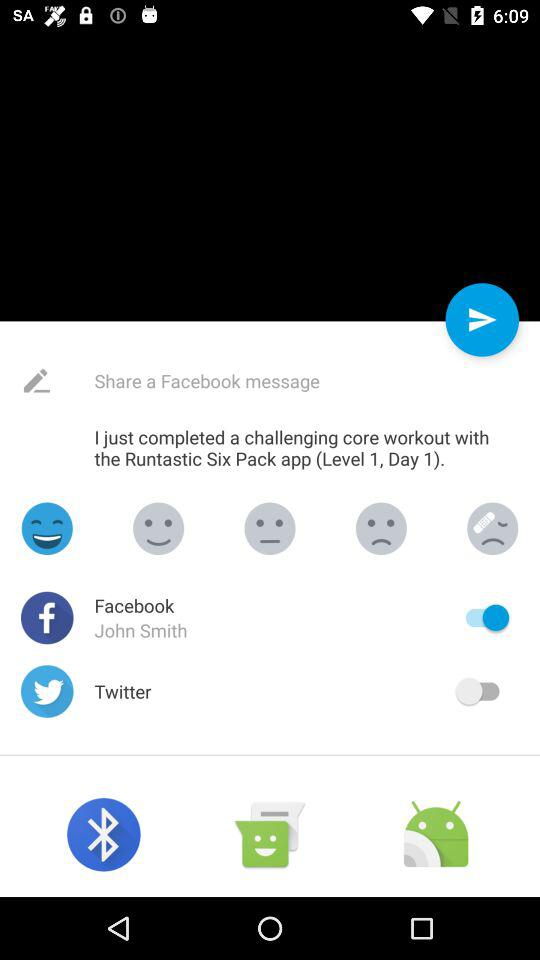What is the status of Facebook? The status is "on". 